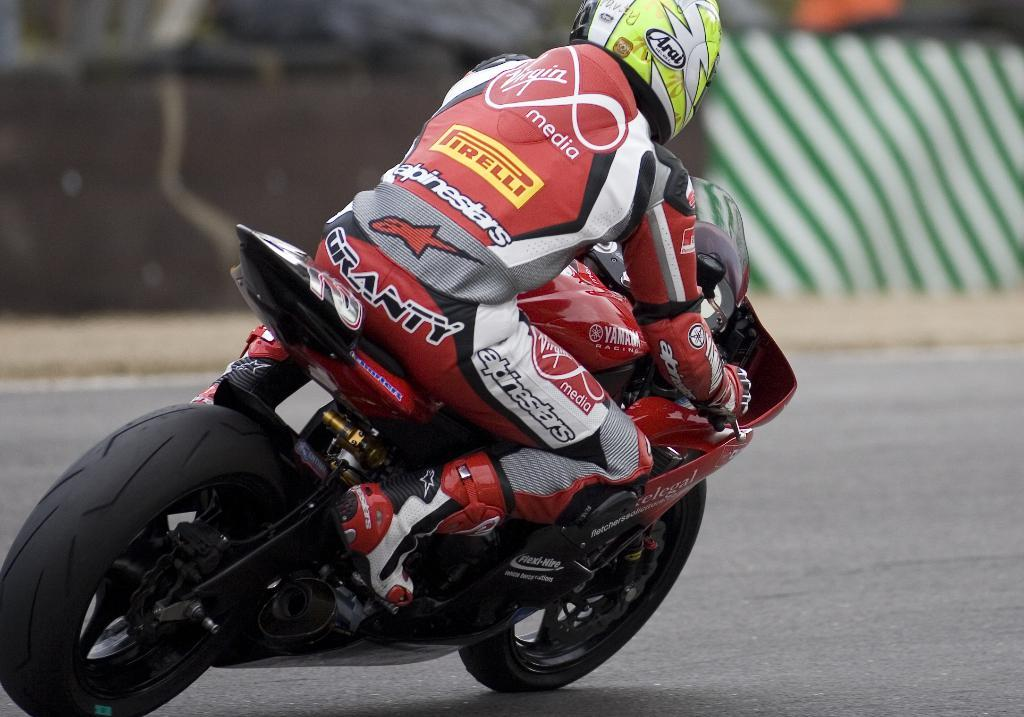What is the main subject of the image? There is a person in the image. What is the person doing in the image? The person is riding a bike. What can be seen in the background of the image? There is a wall in the background of the image. What type of gold jewelry is the person wearing in the image? There is no gold jewelry visible in the image; the person is wearing a helmet and riding a bike. 